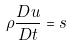<formula> <loc_0><loc_0><loc_500><loc_500>\rho \frac { D u } { D t } = s</formula> 